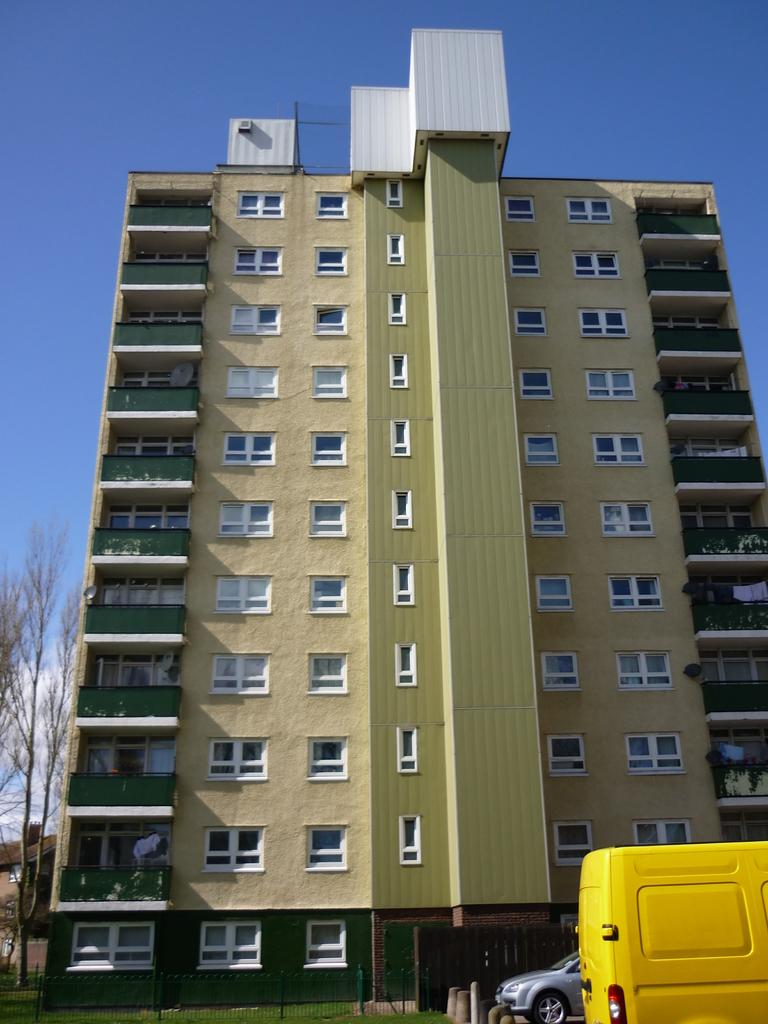What type of structure is visible in the image? There is a building in the image. What else can be seen in the image besides the building? There are vehicles, a fence, grass, trees, and the sky visible in the image. Can you describe the vehicles in the image? The vehicles in the image are not specified, but they are present. What type of natural elements are present in the image? Grass and trees are the natural elements present in the image. What type of club can be seen hanging from the trees in the image? There is no club present in the image, and trees are not mentioned as having anything hanging from them. 